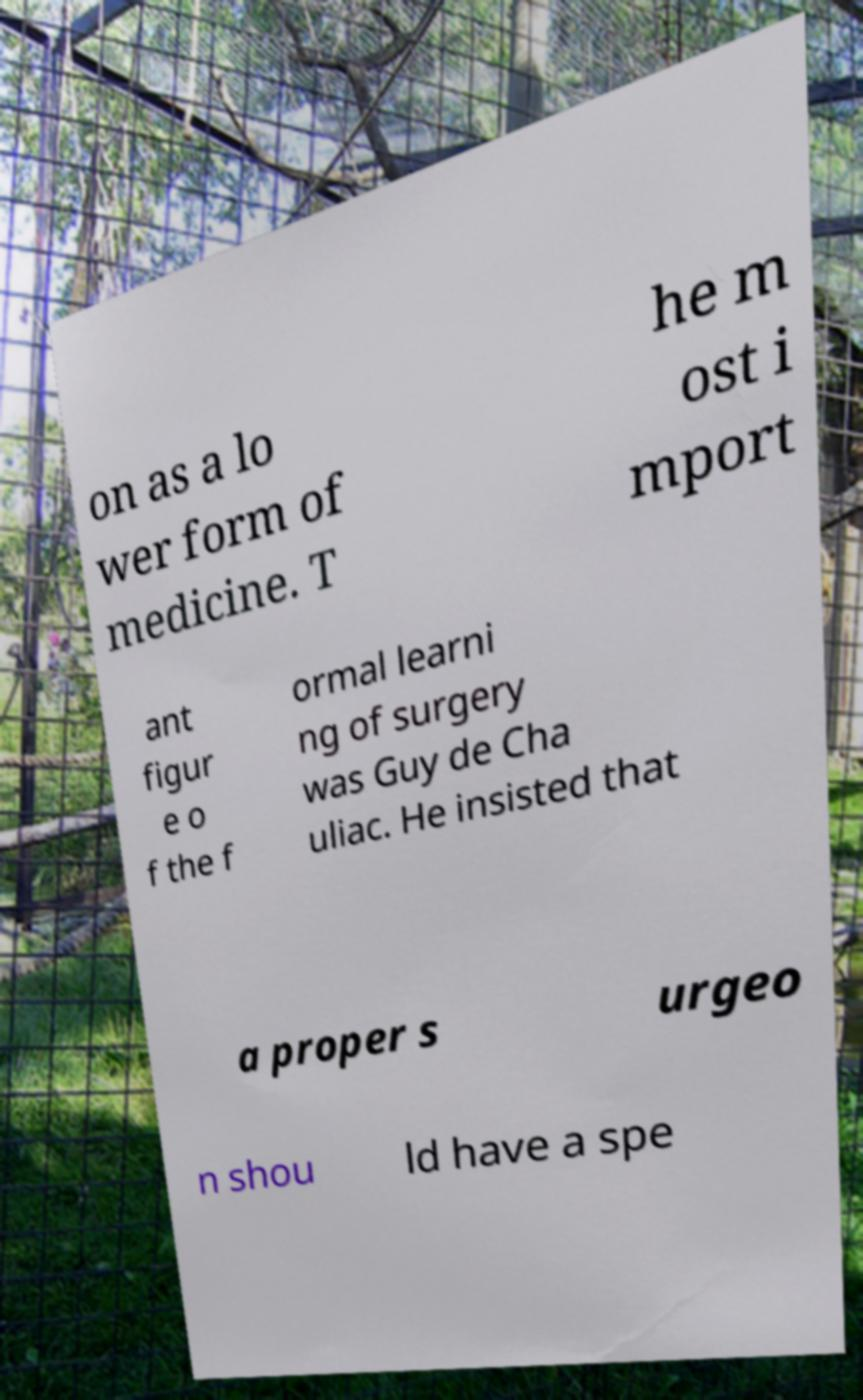Can you accurately transcribe the text from the provided image for me? on as a lo wer form of medicine. T he m ost i mport ant figur e o f the f ormal learni ng of surgery was Guy de Cha uliac. He insisted that a proper s urgeo n shou ld have a spe 